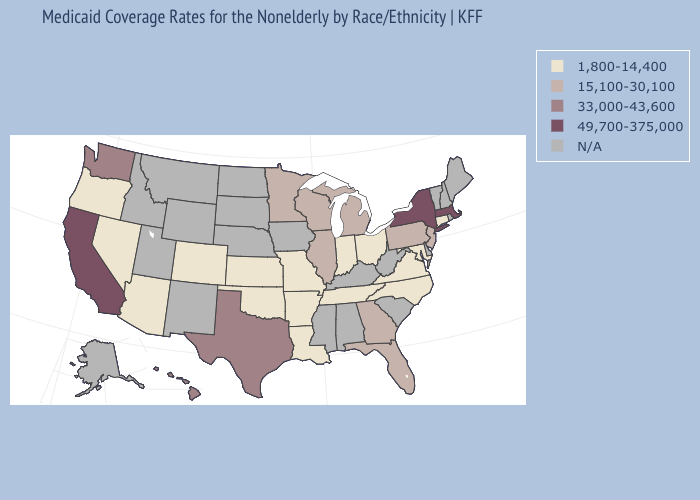Name the states that have a value in the range N/A?
Keep it brief. Alabama, Alaska, Delaware, Idaho, Iowa, Kentucky, Maine, Mississippi, Montana, Nebraska, New Hampshire, New Mexico, North Dakota, Rhode Island, South Carolina, South Dakota, Utah, Vermont, West Virginia, Wyoming. Name the states that have a value in the range 33,000-43,600?
Keep it brief. Hawaii, Texas, Washington. Name the states that have a value in the range 15,100-30,100?
Concise answer only. Florida, Georgia, Illinois, Michigan, Minnesota, New Jersey, Pennsylvania, Wisconsin. Name the states that have a value in the range 49,700-375,000?
Concise answer only. California, Massachusetts, New York. Does New Jersey have the lowest value in the USA?
Answer briefly. No. What is the value of Georgia?
Be succinct. 15,100-30,100. Name the states that have a value in the range 15,100-30,100?
Keep it brief. Florida, Georgia, Illinois, Michigan, Minnesota, New Jersey, Pennsylvania, Wisconsin. Does Missouri have the highest value in the MidWest?
Quick response, please. No. Which states have the lowest value in the USA?
Give a very brief answer. Arizona, Arkansas, Colorado, Connecticut, Indiana, Kansas, Louisiana, Maryland, Missouri, Nevada, North Carolina, Ohio, Oklahoma, Oregon, Tennessee, Virginia. Does Tennessee have the lowest value in the South?
Write a very short answer. Yes. What is the highest value in states that border West Virginia?
Write a very short answer. 15,100-30,100. Name the states that have a value in the range N/A?
Quick response, please. Alabama, Alaska, Delaware, Idaho, Iowa, Kentucky, Maine, Mississippi, Montana, Nebraska, New Hampshire, New Mexico, North Dakota, Rhode Island, South Carolina, South Dakota, Utah, Vermont, West Virginia, Wyoming. Does New Jersey have the highest value in the Northeast?
Be succinct. No. Does North Carolina have the lowest value in the South?
Concise answer only. Yes. 